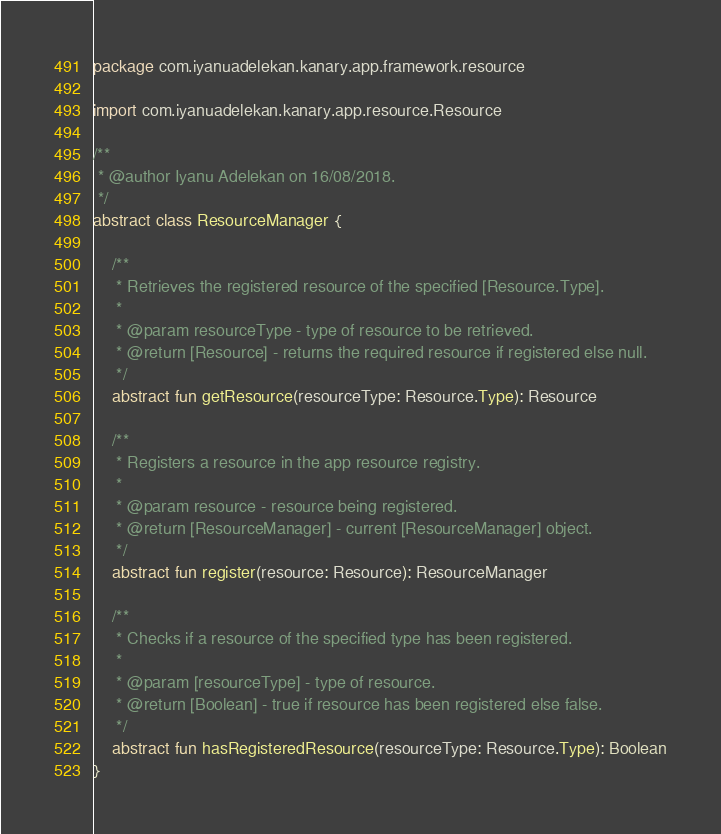<code> <loc_0><loc_0><loc_500><loc_500><_Kotlin_>package com.iyanuadelekan.kanary.app.framework.resource

import com.iyanuadelekan.kanary.app.resource.Resource

/**
 * @author Iyanu Adelekan on 16/08/2018.
 */
abstract class ResourceManager {

    /**
     * Retrieves the registered resource of the specified [Resource.Type].
     *
     * @param resourceType - type of resource to be retrieved.
     * @return [Resource] - returns the required resource if registered else null.
     */
    abstract fun getResource(resourceType: Resource.Type): Resource

    /**
     * Registers a resource in the app resource registry.
     *
     * @param resource - resource being registered.
     * @return [ResourceManager] - current [ResourceManager] object.
     */
    abstract fun register(resource: Resource): ResourceManager

    /**
     * Checks if a resource of the specified type has been registered.
     *
     * @param [resourceType] - type of resource.
     * @return [Boolean] - true if resource has been registered else false.
     */
    abstract fun hasRegisteredResource(resourceType: Resource.Type): Boolean
}</code> 